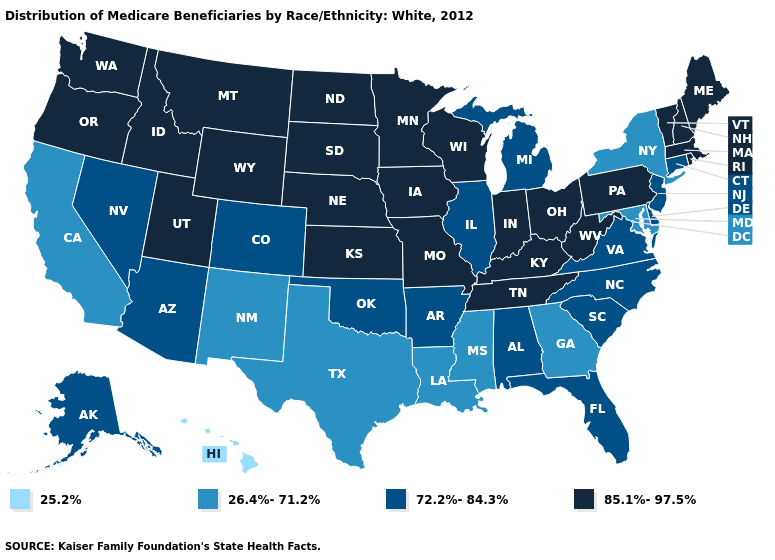What is the value of North Carolina?
Short answer required. 72.2%-84.3%. Name the states that have a value in the range 72.2%-84.3%?
Be succinct. Alabama, Alaska, Arizona, Arkansas, Colorado, Connecticut, Delaware, Florida, Illinois, Michigan, Nevada, New Jersey, North Carolina, Oklahoma, South Carolina, Virginia. Does the map have missing data?
Give a very brief answer. No. What is the value of North Carolina?
Write a very short answer. 72.2%-84.3%. Does Missouri have the highest value in the USA?
Be succinct. Yes. Name the states that have a value in the range 72.2%-84.3%?
Quick response, please. Alabama, Alaska, Arizona, Arkansas, Colorado, Connecticut, Delaware, Florida, Illinois, Michigan, Nevada, New Jersey, North Carolina, Oklahoma, South Carolina, Virginia. What is the value of Michigan?
Quick response, please. 72.2%-84.3%. Is the legend a continuous bar?
Concise answer only. No. Which states have the highest value in the USA?
Give a very brief answer. Idaho, Indiana, Iowa, Kansas, Kentucky, Maine, Massachusetts, Minnesota, Missouri, Montana, Nebraska, New Hampshire, North Dakota, Ohio, Oregon, Pennsylvania, Rhode Island, South Dakota, Tennessee, Utah, Vermont, Washington, West Virginia, Wisconsin, Wyoming. What is the value of Tennessee?
Give a very brief answer. 85.1%-97.5%. Does the first symbol in the legend represent the smallest category?
Give a very brief answer. Yes. Among the states that border Alabama , does Georgia have the highest value?
Short answer required. No. Name the states that have a value in the range 25.2%?
Give a very brief answer. Hawaii. Name the states that have a value in the range 72.2%-84.3%?
Concise answer only. Alabama, Alaska, Arizona, Arkansas, Colorado, Connecticut, Delaware, Florida, Illinois, Michigan, Nevada, New Jersey, North Carolina, Oklahoma, South Carolina, Virginia. Name the states that have a value in the range 25.2%?
Answer briefly. Hawaii. 